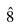<formula> <loc_0><loc_0><loc_500><loc_500>\hat { 8 }</formula> 